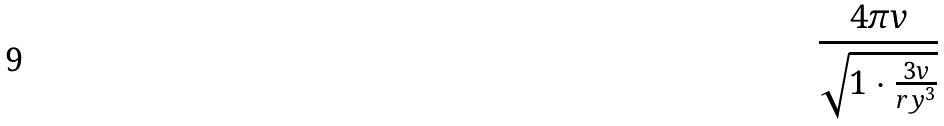<formula> <loc_0><loc_0><loc_500><loc_500>\frac { 4 \pi v } { \sqrt { 1 \cdot \frac { 3 v } { r y ^ { 3 } } } }</formula> 